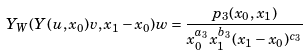Convert formula to latex. <formula><loc_0><loc_0><loc_500><loc_500>Y _ { W } ( Y ( u , x _ { 0 } ) v , x _ { 1 } - x _ { 0 } ) w = \frac { p _ { 3 } ( x _ { 0 } , x _ { 1 } ) } { x _ { 0 } ^ { a _ { 3 } } x _ { 1 } ^ { b _ { 3 } } ( x _ { 1 } - x _ { 0 } ) ^ { c _ { 3 } } }</formula> 